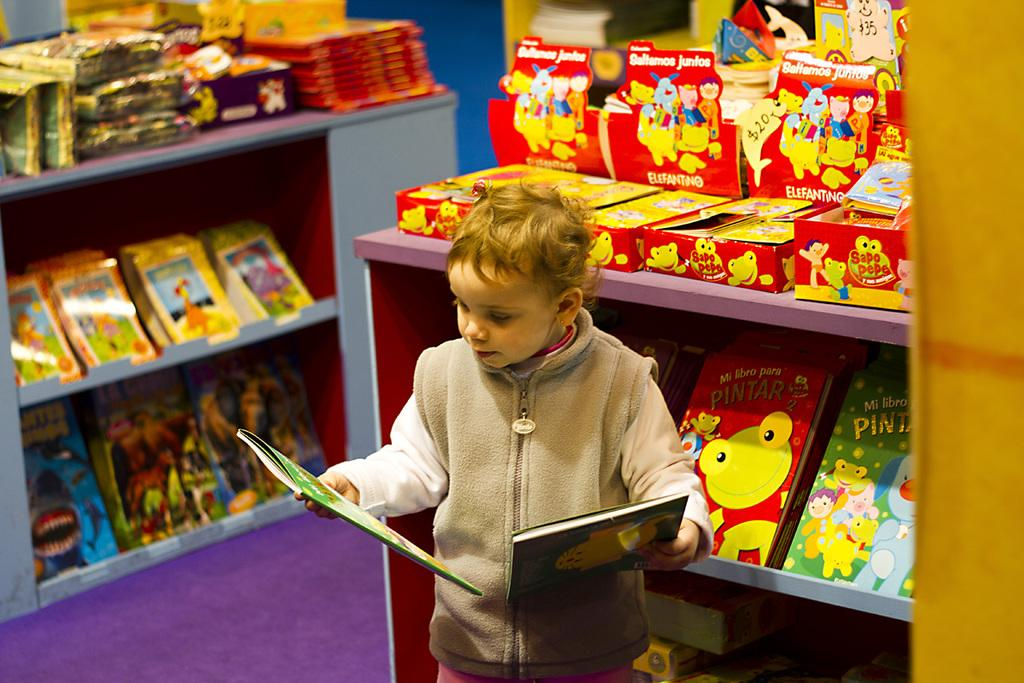<image>
Share a concise interpretation of the image provided. Boy reading books inside a bookstore including one titled "PINTAR". 